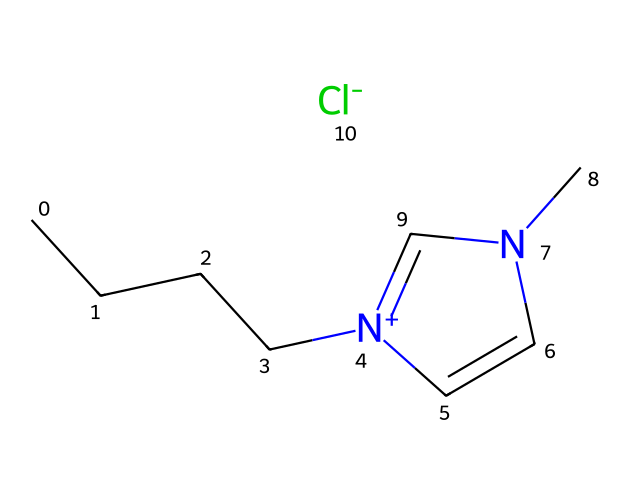what is the molecular formula of this ionic liquid? To determine the molecular formula, we need to count all the carbon (C), hydrogen (H), nitrogen (N), and chlorine (Cl) atoms present in the SMILES representation. There are 8 carbon atoms, 12 hydrogen atoms, 2 nitrogen atoms, and 1 chlorine atom, which gives the molecular formula as C8H12ClN2.
Answer: C8H12ClN2 how many nitrogen atoms are in this compound? By analyzing the SMILES representation, we can identify the nitrogen atoms represented by the letter 'N.' There are 2 instances of 'N,' indicating that there are 2 nitrogen atoms in this structure.
Answer: 2 is this ionic liquid a solid or liquid at room temperature? Ionic liquids generally have low volatility and do not readily evaporate, which often results in them being liquid at room temperature. Given its nature and structure, this ionic liquid would typically be a liquid at room temperature.
Answer: liquid what is the significance of the '[Cl-]' in the structure? The '[Cl-]' in the SMILES notation indicates the presence of a chloride ion, which is the counterion associated with the cation in this ionic liquid. This counterion plays a crucial role in stabilizing the ionic liquid and contributes to its properties.
Answer: counterion how does the structure of this ionic liquid contribute to its antifungal properties? The structure of ionic liquids can influence their antifungal activity due to their unique ionic nature and ability to disrupt fungal cell membranes. The combination of a hydrophobic alkyl chain and the ionic head groups allows the ionic liquid to interact with fungi effectively, leading to cell disruption.
Answer: disrupts cell membranes what type of bonding is primarily found in ionic liquids like this one? Ionic liquids primarily feature ionic bonding between the cation and the anion. In this case, the quaternary ammonium cation and the chloride anion are held together by these ionic interactions, characterizing the essence of ionic liquids.
Answer: ionic bonding how does the presence of aromatic rings affect ionic liquid properties? The presence of aromatic rings in the structure of ionic liquids affects properties such as thermal stability, viscosity, and solubility. Aromatic rings can enhance the interactions between the cation and anion, potentially influencing the overall stability and efficacy of the ionic liquid when used in applications like antifungal treatments.
Answer: enhance stability 